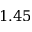<formula> <loc_0><loc_0><loc_500><loc_500>1 . 4 5</formula> 